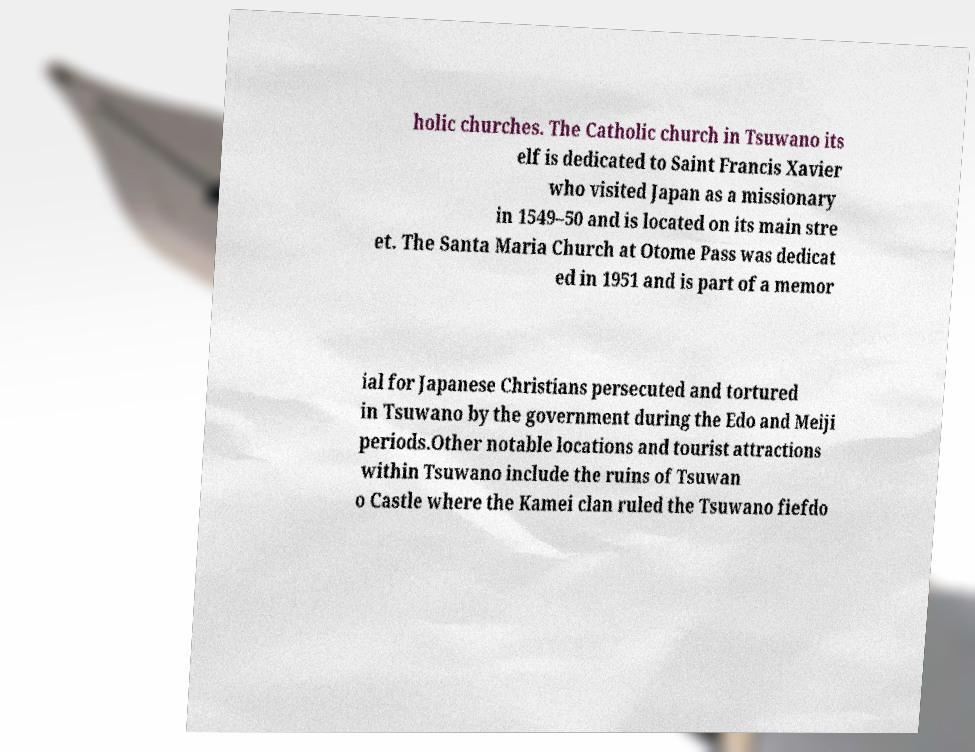For documentation purposes, I need the text within this image transcribed. Could you provide that? holic churches. The Catholic church in Tsuwano its elf is dedicated to Saint Francis Xavier who visited Japan as a missionary in 1549–50 and is located on its main stre et. The Santa Maria Church at Otome Pass was dedicat ed in 1951 and is part of a memor ial for Japanese Christians persecuted and tortured in Tsuwano by the government during the Edo and Meiji periods.Other notable locations and tourist attractions within Tsuwano include the ruins of Tsuwan o Castle where the Kamei clan ruled the Tsuwano fiefdo 